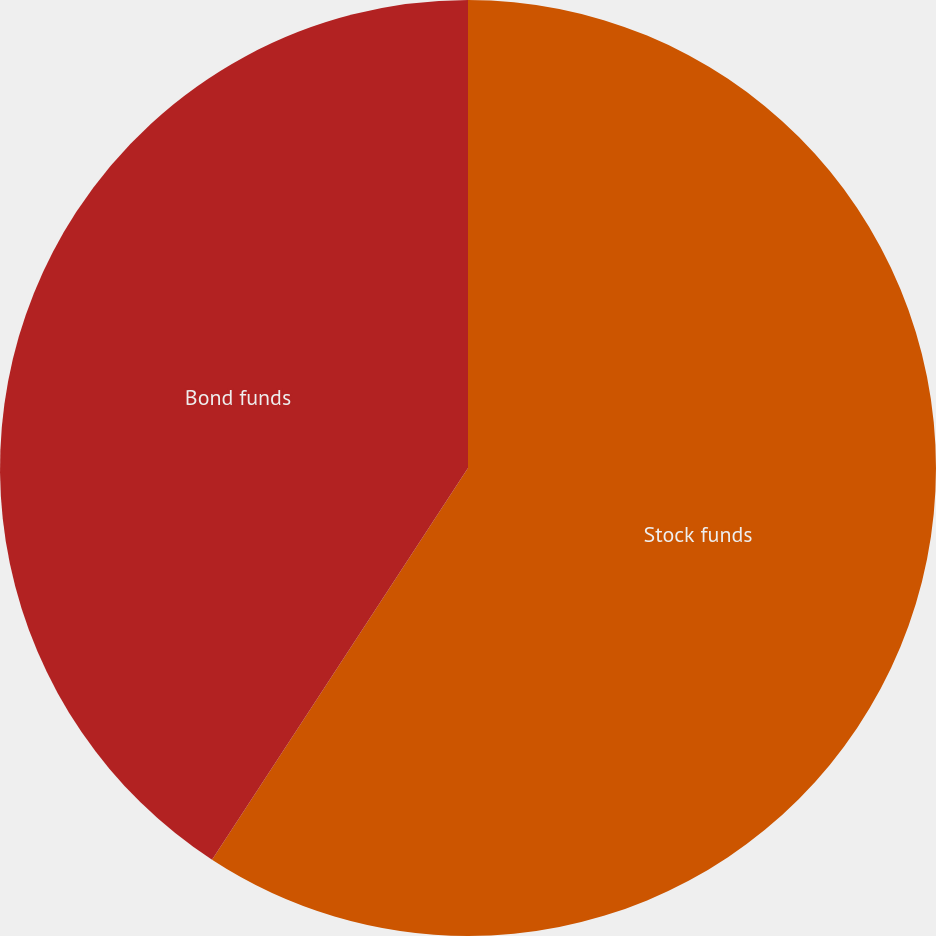<chart> <loc_0><loc_0><loc_500><loc_500><pie_chart><fcel>Stock funds<fcel>Bond funds<nl><fcel>59.21%<fcel>40.79%<nl></chart> 